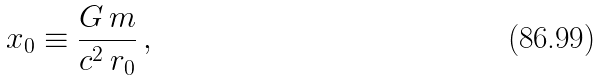Convert formula to latex. <formula><loc_0><loc_0><loc_500><loc_500>x _ { 0 } \equiv \frac { G \, m } { c ^ { 2 } \, r _ { 0 } } \, ,</formula> 